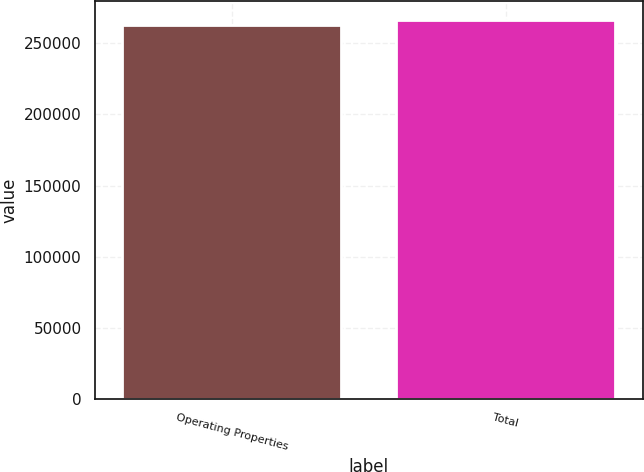<chart> <loc_0><loc_0><loc_500><loc_500><bar_chart><fcel>Operating Properties<fcel>Total<nl><fcel>262792<fcel>266092<nl></chart> 